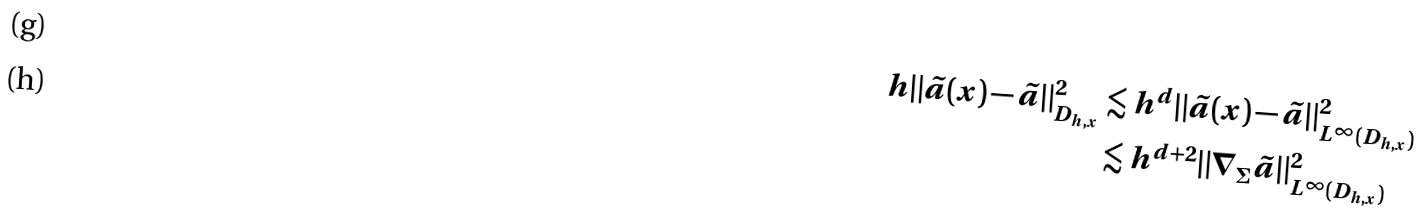Convert formula to latex. <formula><loc_0><loc_0><loc_500><loc_500>h \| \tilde { a } ( x ) - \tilde { a } \| ^ { 2 } _ { D _ { h , x } } & \lesssim h ^ { d } \| \tilde { a } ( x ) - \tilde { a } \| ^ { 2 } _ { L ^ { \infty } ( D _ { h , x } ) } \\ & \lesssim h ^ { d + 2 } \| \nabla _ { \Sigma } \tilde { a } \| ^ { 2 } _ { L ^ { \infty } ( D _ { h , x } ) }</formula> 